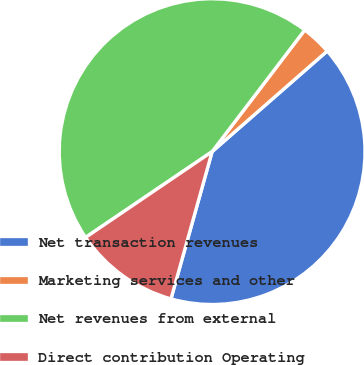<chart> <loc_0><loc_0><loc_500><loc_500><pie_chart><fcel>Net transaction revenues<fcel>Marketing services and other<fcel>Net revenues from external<fcel>Direct contribution Operating<nl><fcel>40.77%<fcel>3.21%<fcel>44.84%<fcel>11.18%<nl></chart> 